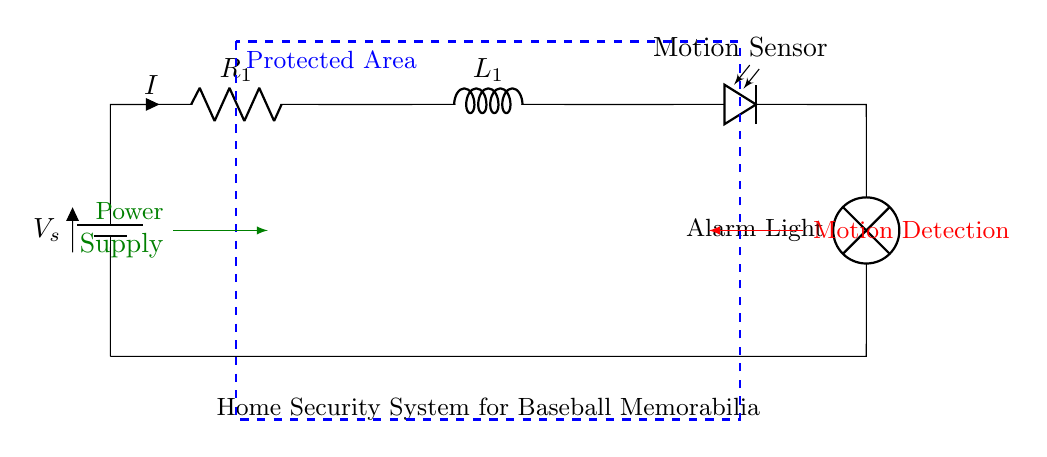What is the type of circuit in the diagram? This circuit is a series circuit because components are connected sequentially, one after the other, forming a single loop through which current flows.
Answer: series circuit What is the function of the motion sensor? The motion sensor detects movement within the protected area, triggering the alarm light if any motion is sensed.
Answer: detects motion What is the total current flowing through the circuit? The current in a series circuit is the same through every component. Therefore, the current is represented as I in the circuit, but no numerical value is provided in the diagram.
Answer: I What component is indicated as providing power in this circuit? The power supply is indicated in the diagram, shown as a component supplying energy to the circuit, allowing all other components to function.
Answer: power supply What indicates the protected area in the diagram? A blue dashed rectangle surrounds the components, clearly marking the area that is protected by the home security system.
Answer: protected area What happens to the alarm light when motion is detected? When the motion sensor activates due to detected movement, it allows current to flow through the circuit, turning on the lamp designated as the alarm light.
Answer: turns on What role does the resistor play in this circuit? The resistor controls the current flow in the circuit, helping to prevent excessive current that could damage components or lead to false alarms.
Answer: controls current 